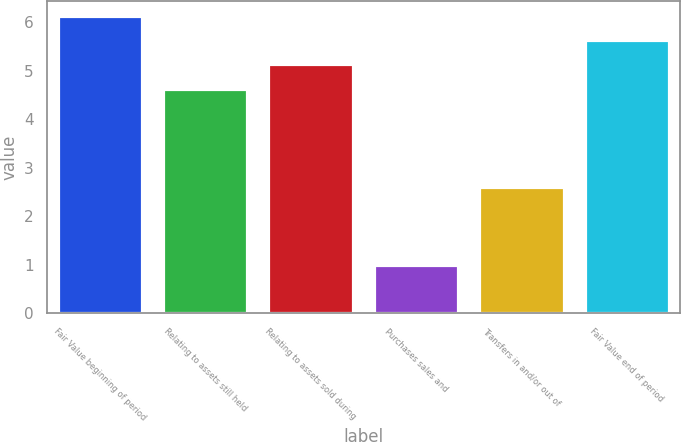<chart> <loc_0><loc_0><loc_500><loc_500><bar_chart><fcel>Fair Value beginning of period<fcel>Relating to assets still held<fcel>Relating to assets sold during<fcel>Purchases sales and<fcel>Transfers in and/or out of<fcel>Fair Value end of period<nl><fcel>6.13<fcel>4.63<fcel>5.13<fcel>1<fcel>2.6<fcel>5.63<nl></chart> 